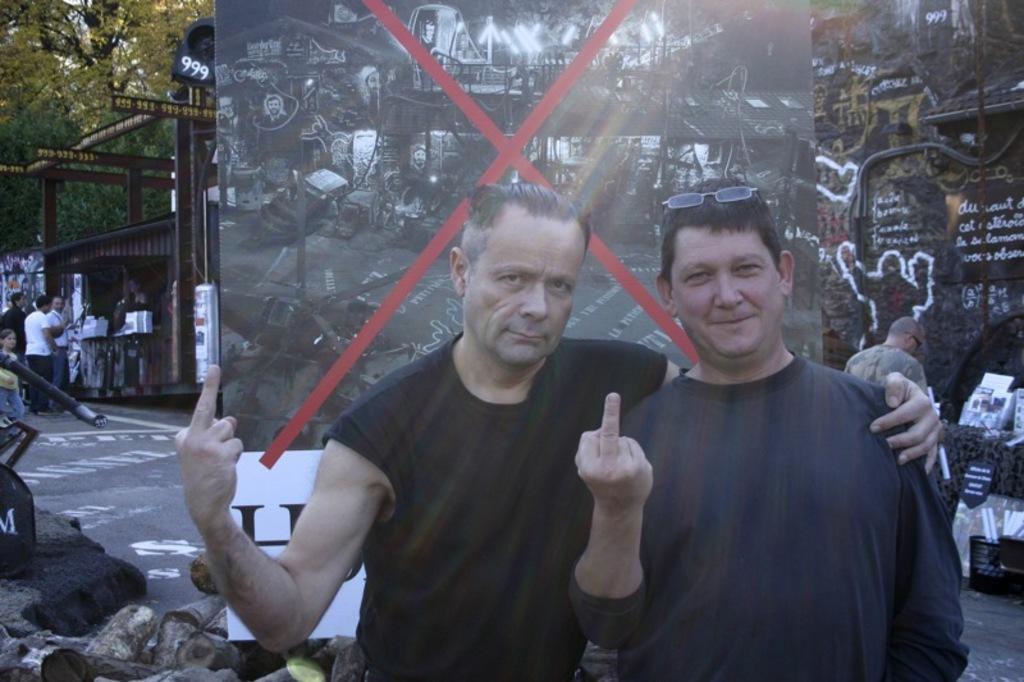Describe this image in one or two sentences. In this picture I can see there are two men standing and the person at the right is having glasses. There is a banner in the backdrop and there is an image on it. There is scrap on the left side and there are a few people standing at left, there is a tree. 